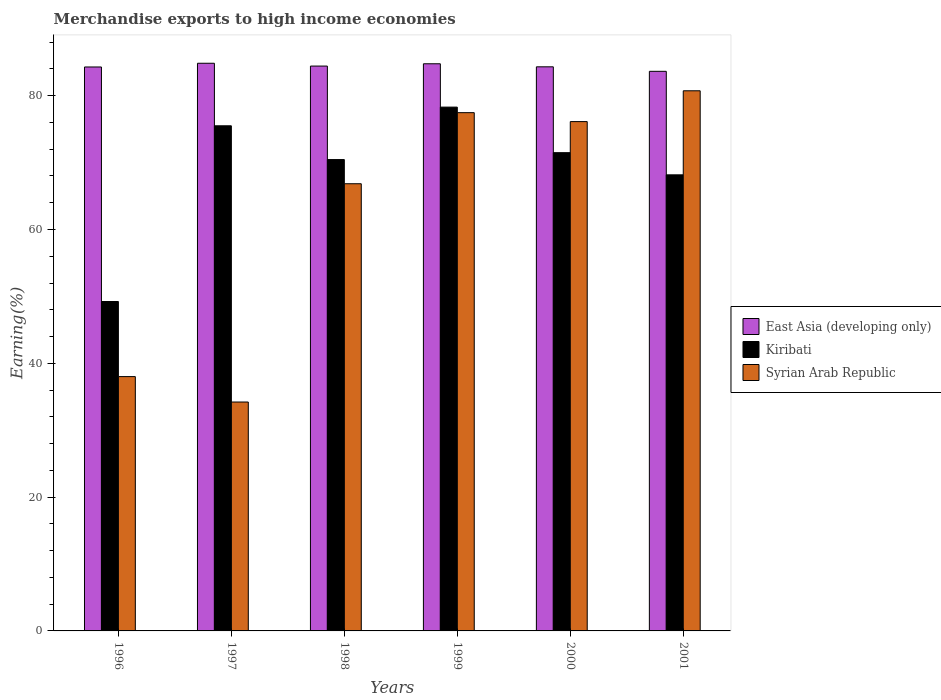How many different coloured bars are there?
Your answer should be compact. 3. How many groups of bars are there?
Offer a very short reply. 6. Are the number of bars per tick equal to the number of legend labels?
Provide a succinct answer. Yes. How many bars are there on the 6th tick from the left?
Offer a terse response. 3. In how many cases, is the number of bars for a given year not equal to the number of legend labels?
Offer a terse response. 0. What is the percentage of amount earned from merchandise exports in Syrian Arab Republic in 1998?
Provide a succinct answer. 66.84. Across all years, what is the maximum percentage of amount earned from merchandise exports in Kiribati?
Keep it short and to the point. 78.29. Across all years, what is the minimum percentage of amount earned from merchandise exports in East Asia (developing only)?
Make the answer very short. 83.64. What is the total percentage of amount earned from merchandise exports in Syrian Arab Republic in the graph?
Provide a short and direct response. 373.38. What is the difference between the percentage of amount earned from merchandise exports in Kiribati in 1996 and that in 1998?
Offer a very short reply. -21.21. What is the difference between the percentage of amount earned from merchandise exports in Kiribati in 2000 and the percentage of amount earned from merchandise exports in Syrian Arab Republic in 1996?
Your answer should be compact. 33.47. What is the average percentage of amount earned from merchandise exports in Kiribati per year?
Your answer should be very brief. 68.85. In the year 2001, what is the difference between the percentage of amount earned from merchandise exports in Kiribati and percentage of amount earned from merchandise exports in East Asia (developing only)?
Offer a terse response. -15.47. What is the ratio of the percentage of amount earned from merchandise exports in Kiribati in 1996 to that in 2000?
Give a very brief answer. 0.69. Is the percentage of amount earned from merchandise exports in Syrian Arab Republic in 1997 less than that in 2000?
Keep it short and to the point. Yes. Is the difference between the percentage of amount earned from merchandise exports in Kiribati in 1999 and 2000 greater than the difference between the percentage of amount earned from merchandise exports in East Asia (developing only) in 1999 and 2000?
Keep it short and to the point. Yes. What is the difference between the highest and the second highest percentage of amount earned from merchandise exports in East Asia (developing only)?
Your response must be concise. 0.08. What is the difference between the highest and the lowest percentage of amount earned from merchandise exports in Kiribati?
Offer a terse response. 29.05. In how many years, is the percentage of amount earned from merchandise exports in Syrian Arab Republic greater than the average percentage of amount earned from merchandise exports in Syrian Arab Republic taken over all years?
Provide a short and direct response. 4. Is the sum of the percentage of amount earned from merchandise exports in East Asia (developing only) in 1999 and 2001 greater than the maximum percentage of amount earned from merchandise exports in Kiribati across all years?
Make the answer very short. Yes. What does the 1st bar from the left in 2000 represents?
Your response must be concise. East Asia (developing only). What does the 1st bar from the right in 2000 represents?
Make the answer very short. Syrian Arab Republic. How many bars are there?
Keep it short and to the point. 18. What is the difference between two consecutive major ticks on the Y-axis?
Make the answer very short. 20. Does the graph contain any zero values?
Offer a very short reply. No. Does the graph contain grids?
Your answer should be compact. No. How are the legend labels stacked?
Give a very brief answer. Vertical. What is the title of the graph?
Offer a terse response. Merchandise exports to high income economies. What is the label or title of the Y-axis?
Your response must be concise. Earning(%). What is the Earning(%) of East Asia (developing only) in 1996?
Your answer should be compact. 84.29. What is the Earning(%) in Kiribati in 1996?
Your answer should be compact. 49.23. What is the Earning(%) of Syrian Arab Republic in 1996?
Keep it short and to the point. 38.01. What is the Earning(%) in East Asia (developing only) in 1997?
Keep it short and to the point. 84.84. What is the Earning(%) in Kiribati in 1997?
Offer a very short reply. 75.5. What is the Earning(%) in Syrian Arab Republic in 1997?
Offer a very short reply. 34.21. What is the Earning(%) of East Asia (developing only) in 1998?
Your answer should be very brief. 84.42. What is the Earning(%) of Kiribati in 1998?
Give a very brief answer. 70.45. What is the Earning(%) in Syrian Arab Republic in 1998?
Keep it short and to the point. 66.84. What is the Earning(%) in East Asia (developing only) in 1999?
Give a very brief answer. 84.77. What is the Earning(%) of Kiribati in 1999?
Your answer should be very brief. 78.29. What is the Earning(%) in Syrian Arab Republic in 1999?
Offer a very short reply. 77.46. What is the Earning(%) in East Asia (developing only) in 2000?
Your answer should be very brief. 84.31. What is the Earning(%) of Kiribati in 2000?
Offer a terse response. 71.48. What is the Earning(%) of Syrian Arab Republic in 2000?
Provide a short and direct response. 76.13. What is the Earning(%) in East Asia (developing only) in 2001?
Your answer should be very brief. 83.64. What is the Earning(%) of Kiribati in 2001?
Offer a very short reply. 68.17. What is the Earning(%) in Syrian Arab Republic in 2001?
Your answer should be very brief. 80.73. Across all years, what is the maximum Earning(%) of East Asia (developing only)?
Offer a very short reply. 84.84. Across all years, what is the maximum Earning(%) of Kiribati?
Your response must be concise. 78.29. Across all years, what is the maximum Earning(%) of Syrian Arab Republic?
Your answer should be compact. 80.73. Across all years, what is the minimum Earning(%) of East Asia (developing only)?
Ensure brevity in your answer.  83.64. Across all years, what is the minimum Earning(%) in Kiribati?
Make the answer very short. 49.23. Across all years, what is the minimum Earning(%) of Syrian Arab Republic?
Provide a succinct answer. 34.21. What is the total Earning(%) in East Asia (developing only) in the graph?
Your answer should be very brief. 506.28. What is the total Earning(%) in Kiribati in the graph?
Give a very brief answer. 413.12. What is the total Earning(%) in Syrian Arab Republic in the graph?
Keep it short and to the point. 373.38. What is the difference between the Earning(%) in East Asia (developing only) in 1996 and that in 1997?
Your response must be concise. -0.56. What is the difference between the Earning(%) in Kiribati in 1996 and that in 1997?
Your response must be concise. -26.26. What is the difference between the Earning(%) in Syrian Arab Republic in 1996 and that in 1997?
Your answer should be compact. 3.8. What is the difference between the Earning(%) of East Asia (developing only) in 1996 and that in 1998?
Your answer should be very brief. -0.14. What is the difference between the Earning(%) of Kiribati in 1996 and that in 1998?
Keep it short and to the point. -21.21. What is the difference between the Earning(%) of Syrian Arab Republic in 1996 and that in 1998?
Provide a short and direct response. -28.82. What is the difference between the Earning(%) in East Asia (developing only) in 1996 and that in 1999?
Ensure brevity in your answer.  -0.48. What is the difference between the Earning(%) of Kiribati in 1996 and that in 1999?
Keep it short and to the point. -29.05. What is the difference between the Earning(%) in Syrian Arab Republic in 1996 and that in 1999?
Provide a succinct answer. -39.45. What is the difference between the Earning(%) in East Asia (developing only) in 1996 and that in 2000?
Provide a short and direct response. -0.03. What is the difference between the Earning(%) of Kiribati in 1996 and that in 2000?
Offer a terse response. -22.25. What is the difference between the Earning(%) of Syrian Arab Republic in 1996 and that in 2000?
Give a very brief answer. -38.11. What is the difference between the Earning(%) in East Asia (developing only) in 1996 and that in 2001?
Keep it short and to the point. 0.65. What is the difference between the Earning(%) in Kiribati in 1996 and that in 2001?
Offer a terse response. -18.93. What is the difference between the Earning(%) in Syrian Arab Republic in 1996 and that in 2001?
Your answer should be compact. -42.72. What is the difference between the Earning(%) in East Asia (developing only) in 1997 and that in 1998?
Offer a terse response. 0.42. What is the difference between the Earning(%) of Kiribati in 1997 and that in 1998?
Your answer should be compact. 5.05. What is the difference between the Earning(%) in Syrian Arab Republic in 1997 and that in 1998?
Offer a very short reply. -32.62. What is the difference between the Earning(%) in East Asia (developing only) in 1997 and that in 1999?
Offer a terse response. 0.08. What is the difference between the Earning(%) in Kiribati in 1997 and that in 1999?
Your answer should be compact. -2.79. What is the difference between the Earning(%) of Syrian Arab Republic in 1997 and that in 1999?
Your answer should be very brief. -43.25. What is the difference between the Earning(%) of East Asia (developing only) in 1997 and that in 2000?
Your answer should be very brief. 0.53. What is the difference between the Earning(%) of Kiribati in 1997 and that in 2000?
Provide a succinct answer. 4.02. What is the difference between the Earning(%) of Syrian Arab Republic in 1997 and that in 2000?
Your answer should be very brief. -41.91. What is the difference between the Earning(%) of East Asia (developing only) in 1997 and that in 2001?
Your answer should be compact. 1.2. What is the difference between the Earning(%) of Kiribati in 1997 and that in 2001?
Your answer should be compact. 7.33. What is the difference between the Earning(%) of Syrian Arab Republic in 1997 and that in 2001?
Your answer should be very brief. -46.52. What is the difference between the Earning(%) of East Asia (developing only) in 1998 and that in 1999?
Offer a very short reply. -0.34. What is the difference between the Earning(%) in Kiribati in 1998 and that in 1999?
Provide a short and direct response. -7.84. What is the difference between the Earning(%) of Syrian Arab Republic in 1998 and that in 1999?
Your answer should be compact. -10.62. What is the difference between the Earning(%) in East Asia (developing only) in 1998 and that in 2000?
Your answer should be very brief. 0.11. What is the difference between the Earning(%) in Kiribati in 1998 and that in 2000?
Your response must be concise. -1.03. What is the difference between the Earning(%) of Syrian Arab Republic in 1998 and that in 2000?
Keep it short and to the point. -9.29. What is the difference between the Earning(%) of East Asia (developing only) in 1998 and that in 2001?
Your answer should be compact. 0.78. What is the difference between the Earning(%) of Kiribati in 1998 and that in 2001?
Offer a terse response. 2.28. What is the difference between the Earning(%) in Syrian Arab Republic in 1998 and that in 2001?
Keep it short and to the point. -13.89. What is the difference between the Earning(%) in East Asia (developing only) in 1999 and that in 2000?
Offer a terse response. 0.45. What is the difference between the Earning(%) of Kiribati in 1999 and that in 2000?
Provide a succinct answer. 6.81. What is the difference between the Earning(%) in Syrian Arab Republic in 1999 and that in 2000?
Provide a succinct answer. 1.33. What is the difference between the Earning(%) of East Asia (developing only) in 1999 and that in 2001?
Your answer should be compact. 1.13. What is the difference between the Earning(%) in Kiribati in 1999 and that in 2001?
Ensure brevity in your answer.  10.12. What is the difference between the Earning(%) of Syrian Arab Republic in 1999 and that in 2001?
Give a very brief answer. -3.27. What is the difference between the Earning(%) in East Asia (developing only) in 2000 and that in 2001?
Make the answer very short. 0.67. What is the difference between the Earning(%) of Kiribati in 2000 and that in 2001?
Ensure brevity in your answer.  3.31. What is the difference between the Earning(%) of Syrian Arab Republic in 2000 and that in 2001?
Your response must be concise. -4.61. What is the difference between the Earning(%) of East Asia (developing only) in 1996 and the Earning(%) of Kiribati in 1997?
Keep it short and to the point. 8.79. What is the difference between the Earning(%) of East Asia (developing only) in 1996 and the Earning(%) of Syrian Arab Republic in 1997?
Offer a very short reply. 50.08. What is the difference between the Earning(%) in Kiribati in 1996 and the Earning(%) in Syrian Arab Republic in 1997?
Provide a succinct answer. 15.02. What is the difference between the Earning(%) in East Asia (developing only) in 1996 and the Earning(%) in Kiribati in 1998?
Your answer should be compact. 13.84. What is the difference between the Earning(%) in East Asia (developing only) in 1996 and the Earning(%) in Syrian Arab Republic in 1998?
Offer a very short reply. 17.45. What is the difference between the Earning(%) in Kiribati in 1996 and the Earning(%) in Syrian Arab Republic in 1998?
Your answer should be compact. -17.6. What is the difference between the Earning(%) of East Asia (developing only) in 1996 and the Earning(%) of Kiribati in 1999?
Make the answer very short. 6. What is the difference between the Earning(%) in East Asia (developing only) in 1996 and the Earning(%) in Syrian Arab Republic in 1999?
Provide a succinct answer. 6.83. What is the difference between the Earning(%) of Kiribati in 1996 and the Earning(%) of Syrian Arab Republic in 1999?
Your answer should be very brief. -28.22. What is the difference between the Earning(%) of East Asia (developing only) in 1996 and the Earning(%) of Kiribati in 2000?
Make the answer very short. 12.81. What is the difference between the Earning(%) in East Asia (developing only) in 1996 and the Earning(%) in Syrian Arab Republic in 2000?
Offer a terse response. 8.16. What is the difference between the Earning(%) in Kiribati in 1996 and the Earning(%) in Syrian Arab Republic in 2000?
Make the answer very short. -26.89. What is the difference between the Earning(%) in East Asia (developing only) in 1996 and the Earning(%) in Kiribati in 2001?
Provide a short and direct response. 16.12. What is the difference between the Earning(%) of East Asia (developing only) in 1996 and the Earning(%) of Syrian Arab Republic in 2001?
Your answer should be compact. 3.56. What is the difference between the Earning(%) of Kiribati in 1996 and the Earning(%) of Syrian Arab Republic in 2001?
Offer a very short reply. -31.5. What is the difference between the Earning(%) in East Asia (developing only) in 1997 and the Earning(%) in Kiribati in 1998?
Your response must be concise. 14.4. What is the difference between the Earning(%) in East Asia (developing only) in 1997 and the Earning(%) in Syrian Arab Republic in 1998?
Provide a short and direct response. 18.01. What is the difference between the Earning(%) of Kiribati in 1997 and the Earning(%) of Syrian Arab Republic in 1998?
Your answer should be very brief. 8.66. What is the difference between the Earning(%) in East Asia (developing only) in 1997 and the Earning(%) in Kiribati in 1999?
Provide a succinct answer. 6.56. What is the difference between the Earning(%) of East Asia (developing only) in 1997 and the Earning(%) of Syrian Arab Republic in 1999?
Your answer should be compact. 7.39. What is the difference between the Earning(%) in Kiribati in 1997 and the Earning(%) in Syrian Arab Republic in 1999?
Provide a succinct answer. -1.96. What is the difference between the Earning(%) of East Asia (developing only) in 1997 and the Earning(%) of Kiribati in 2000?
Make the answer very short. 13.36. What is the difference between the Earning(%) of East Asia (developing only) in 1997 and the Earning(%) of Syrian Arab Republic in 2000?
Offer a terse response. 8.72. What is the difference between the Earning(%) in Kiribati in 1997 and the Earning(%) in Syrian Arab Republic in 2000?
Make the answer very short. -0.63. What is the difference between the Earning(%) of East Asia (developing only) in 1997 and the Earning(%) of Kiribati in 2001?
Keep it short and to the point. 16.68. What is the difference between the Earning(%) of East Asia (developing only) in 1997 and the Earning(%) of Syrian Arab Republic in 2001?
Make the answer very short. 4.11. What is the difference between the Earning(%) of Kiribati in 1997 and the Earning(%) of Syrian Arab Republic in 2001?
Offer a terse response. -5.23. What is the difference between the Earning(%) of East Asia (developing only) in 1998 and the Earning(%) of Kiribati in 1999?
Make the answer very short. 6.13. What is the difference between the Earning(%) in East Asia (developing only) in 1998 and the Earning(%) in Syrian Arab Republic in 1999?
Give a very brief answer. 6.96. What is the difference between the Earning(%) of Kiribati in 1998 and the Earning(%) of Syrian Arab Republic in 1999?
Keep it short and to the point. -7.01. What is the difference between the Earning(%) in East Asia (developing only) in 1998 and the Earning(%) in Kiribati in 2000?
Make the answer very short. 12.94. What is the difference between the Earning(%) of East Asia (developing only) in 1998 and the Earning(%) of Syrian Arab Republic in 2000?
Give a very brief answer. 8.3. What is the difference between the Earning(%) in Kiribati in 1998 and the Earning(%) in Syrian Arab Republic in 2000?
Offer a very short reply. -5.68. What is the difference between the Earning(%) of East Asia (developing only) in 1998 and the Earning(%) of Kiribati in 2001?
Offer a terse response. 16.25. What is the difference between the Earning(%) in East Asia (developing only) in 1998 and the Earning(%) in Syrian Arab Republic in 2001?
Offer a terse response. 3.69. What is the difference between the Earning(%) in Kiribati in 1998 and the Earning(%) in Syrian Arab Republic in 2001?
Give a very brief answer. -10.28. What is the difference between the Earning(%) of East Asia (developing only) in 1999 and the Earning(%) of Kiribati in 2000?
Keep it short and to the point. 13.29. What is the difference between the Earning(%) in East Asia (developing only) in 1999 and the Earning(%) in Syrian Arab Republic in 2000?
Make the answer very short. 8.64. What is the difference between the Earning(%) of Kiribati in 1999 and the Earning(%) of Syrian Arab Republic in 2000?
Offer a terse response. 2.16. What is the difference between the Earning(%) in East Asia (developing only) in 1999 and the Earning(%) in Kiribati in 2001?
Your answer should be very brief. 16.6. What is the difference between the Earning(%) of East Asia (developing only) in 1999 and the Earning(%) of Syrian Arab Republic in 2001?
Your answer should be very brief. 4.04. What is the difference between the Earning(%) of Kiribati in 1999 and the Earning(%) of Syrian Arab Republic in 2001?
Make the answer very short. -2.44. What is the difference between the Earning(%) in East Asia (developing only) in 2000 and the Earning(%) in Kiribati in 2001?
Provide a succinct answer. 16.14. What is the difference between the Earning(%) in East Asia (developing only) in 2000 and the Earning(%) in Syrian Arab Republic in 2001?
Provide a short and direct response. 3.58. What is the difference between the Earning(%) in Kiribati in 2000 and the Earning(%) in Syrian Arab Republic in 2001?
Ensure brevity in your answer.  -9.25. What is the average Earning(%) of East Asia (developing only) per year?
Offer a terse response. 84.38. What is the average Earning(%) of Kiribati per year?
Give a very brief answer. 68.85. What is the average Earning(%) of Syrian Arab Republic per year?
Your answer should be very brief. 62.23. In the year 1996, what is the difference between the Earning(%) of East Asia (developing only) and Earning(%) of Kiribati?
Your answer should be very brief. 35.05. In the year 1996, what is the difference between the Earning(%) of East Asia (developing only) and Earning(%) of Syrian Arab Republic?
Give a very brief answer. 46.28. In the year 1996, what is the difference between the Earning(%) in Kiribati and Earning(%) in Syrian Arab Republic?
Provide a short and direct response. 11.22. In the year 1997, what is the difference between the Earning(%) of East Asia (developing only) and Earning(%) of Kiribati?
Keep it short and to the point. 9.35. In the year 1997, what is the difference between the Earning(%) of East Asia (developing only) and Earning(%) of Syrian Arab Republic?
Keep it short and to the point. 50.63. In the year 1997, what is the difference between the Earning(%) in Kiribati and Earning(%) in Syrian Arab Republic?
Make the answer very short. 41.28. In the year 1998, what is the difference between the Earning(%) of East Asia (developing only) and Earning(%) of Kiribati?
Give a very brief answer. 13.97. In the year 1998, what is the difference between the Earning(%) in East Asia (developing only) and Earning(%) in Syrian Arab Republic?
Ensure brevity in your answer.  17.59. In the year 1998, what is the difference between the Earning(%) of Kiribati and Earning(%) of Syrian Arab Republic?
Offer a very short reply. 3.61. In the year 1999, what is the difference between the Earning(%) in East Asia (developing only) and Earning(%) in Kiribati?
Your response must be concise. 6.48. In the year 1999, what is the difference between the Earning(%) in East Asia (developing only) and Earning(%) in Syrian Arab Republic?
Ensure brevity in your answer.  7.31. In the year 1999, what is the difference between the Earning(%) of Kiribati and Earning(%) of Syrian Arab Republic?
Your answer should be very brief. 0.83. In the year 2000, what is the difference between the Earning(%) in East Asia (developing only) and Earning(%) in Kiribati?
Ensure brevity in your answer.  12.83. In the year 2000, what is the difference between the Earning(%) in East Asia (developing only) and Earning(%) in Syrian Arab Republic?
Your answer should be compact. 8.19. In the year 2000, what is the difference between the Earning(%) of Kiribati and Earning(%) of Syrian Arab Republic?
Offer a very short reply. -4.64. In the year 2001, what is the difference between the Earning(%) in East Asia (developing only) and Earning(%) in Kiribati?
Give a very brief answer. 15.47. In the year 2001, what is the difference between the Earning(%) of East Asia (developing only) and Earning(%) of Syrian Arab Republic?
Offer a terse response. 2.91. In the year 2001, what is the difference between the Earning(%) in Kiribati and Earning(%) in Syrian Arab Republic?
Your answer should be very brief. -12.56. What is the ratio of the Earning(%) of East Asia (developing only) in 1996 to that in 1997?
Your response must be concise. 0.99. What is the ratio of the Earning(%) of Kiribati in 1996 to that in 1997?
Ensure brevity in your answer.  0.65. What is the ratio of the Earning(%) in Syrian Arab Republic in 1996 to that in 1997?
Provide a short and direct response. 1.11. What is the ratio of the Earning(%) in Kiribati in 1996 to that in 1998?
Offer a very short reply. 0.7. What is the ratio of the Earning(%) in Syrian Arab Republic in 1996 to that in 1998?
Your response must be concise. 0.57. What is the ratio of the Earning(%) of East Asia (developing only) in 1996 to that in 1999?
Your answer should be very brief. 0.99. What is the ratio of the Earning(%) in Kiribati in 1996 to that in 1999?
Make the answer very short. 0.63. What is the ratio of the Earning(%) of Syrian Arab Republic in 1996 to that in 1999?
Ensure brevity in your answer.  0.49. What is the ratio of the Earning(%) in East Asia (developing only) in 1996 to that in 2000?
Your answer should be compact. 1. What is the ratio of the Earning(%) in Kiribati in 1996 to that in 2000?
Offer a very short reply. 0.69. What is the ratio of the Earning(%) in Syrian Arab Republic in 1996 to that in 2000?
Your response must be concise. 0.5. What is the ratio of the Earning(%) in East Asia (developing only) in 1996 to that in 2001?
Provide a short and direct response. 1.01. What is the ratio of the Earning(%) of Kiribati in 1996 to that in 2001?
Provide a succinct answer. 0.72. What is the ratio of the Earning(%) of Syrian Arab Republic in 1996 to that in 2001?
Ensure brevity in your answer.  0.47. What is the ratio of the Earning(%) in East Asia (developing only) in 1997 to that in 1998?
Keep it short and to the point. 1. What is the ratio of the Earning(%) in Kiribati in 1997 to that in 1998?
Provide a succinct answer. 1.07. What is the ratio of the Earning(%) in Syrian Arab Republic in 1997 to that in 1998?
Give a very brief answer. 0.51. What is the ratio of the Earning(%) in Kiribati in 1997 to that in 1999?
Provide a short and direct response. 0.96. What is the ratio of the Earning(%) of Syrian Arab Republic in 1997 to that in 1999?
Provide a short and direct response. 0.44. What is the ratio of the Earning(%) of Kiribati in 1997 to that in 2000?
Provide a short and direct response. 1.06. What is the ratio of the Earning(%) in Syrian Arab Republic in 1997 to that in 2000?
Provide a short and direct response. 0.45. What is the ratio of the Earning(%) of East Asia (developing only) in 1997 to that in 2001?
Your answer should be very brief. 1.01. What is the ratio of the Earning(%) of Kiribati in 1997 to that in 2001?
Make the answer very short. 1.11. What is the ratio of the Earning(%) of Syrian Arab Republic in 1997 to that in 2001?
Your answer should be compact. 0.42. What is the ratio of the Earning(%) of Kiribati in 1998 to that in 1999?
Your answer should be very brief. 0.9. What is the ratio of the Earning(%) in Syrian Arab Republic in 1998 to that in 1999?
Your response must be concise. 0.86. What is the ratio of the Earning(%) in East Asia (developing only) in 1998 to that in 2000?
Provide a short and direct response. 1. What is the ratio of the Earning(%) of Kiribati in 1998 to that in 2000?
Keep it short and to the point. 0.99. What is the ratio of the Earning(%) in Syrian Arab Republic in 1998 to that in 2000?
Your answer should be compact. 0.88. What is the ratio of the Earning(%) of East Asia (developing only) in 1998 to that in 2001?
Give a very brief answer. 1.01. What is the ratio of the Earning(%) of Kiribati in 1998 to that in 2001?
Provide a short and direct response. 1.03. What is the ratio of the Earning(%) in Syrian Arab Republic in 1998 to that in 2001?
Keep it short and to the point. 0.83. What is the ratio of the Earning(%) of East Asia (developing only) in 1999 to that in 2000?
Provide a short and direct response. 1.01. What is the ratio of the Earning(%) in Kiribati in 1999 to that in 2000?
Make the answer very short. 1.1. What is the ratio of the Earning(%) of Syrian Arab Republic in 1999 to that in 2000?
Offer a very short reply. 1.02. What is the ratio of the Earning(%) of East Asia (developing only) in 1999 to that in 2001?
Your response must be concise. 1.01. What is the ratio of the Earning(%) of Kiribati in 1999 to that in 2001?
Provide a short and direct response. 1.15. What is the ratio of the Earning(%) of Syrian Arab Republic in 1999 to that in 2001?
Offer a terse response. 0.96. What is the ratio of the Earning(%) of Kiribati in 2000 to that in 2001?
Offer a terse response. 1.05. What is the ratio of the Earning(%) of Syrian Arab Republic in 2000 to that in 2001?
Your answer should be very brief. 0.94. What is the difference between the highest and the second highest Earning(%) in East Asia (developing only)?
Your answer should be compact. 0.08. What is the difference between the highest and the second highest Earning(%) of Kiribati?
Provide a succinct answer. 2.79. What is the difference between the highest and the second highest Earning(%) in Syrian Arab Republic?
Make the answer very short. 3.27. What is the difference between the highest and the lowest Earning(%) in East Asia (developing only)?
Offer a terse response. 1.2. What is the difference between the highest and the lowest Earning(%) in Kiribati?
Offer a terse response. 29.05. What is the difference between the highest and the lowest Earning(%) in Syrian Arab Republic?
Provide a short and direct response. 46.52. 